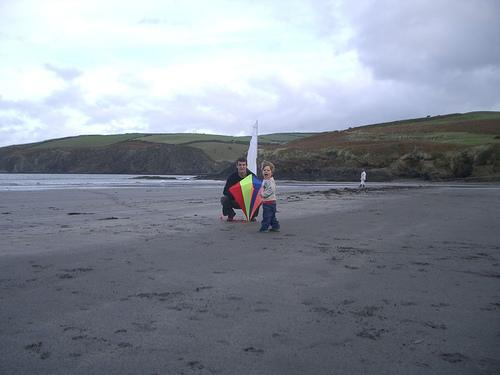What will this child hold while they play with this toy? string 